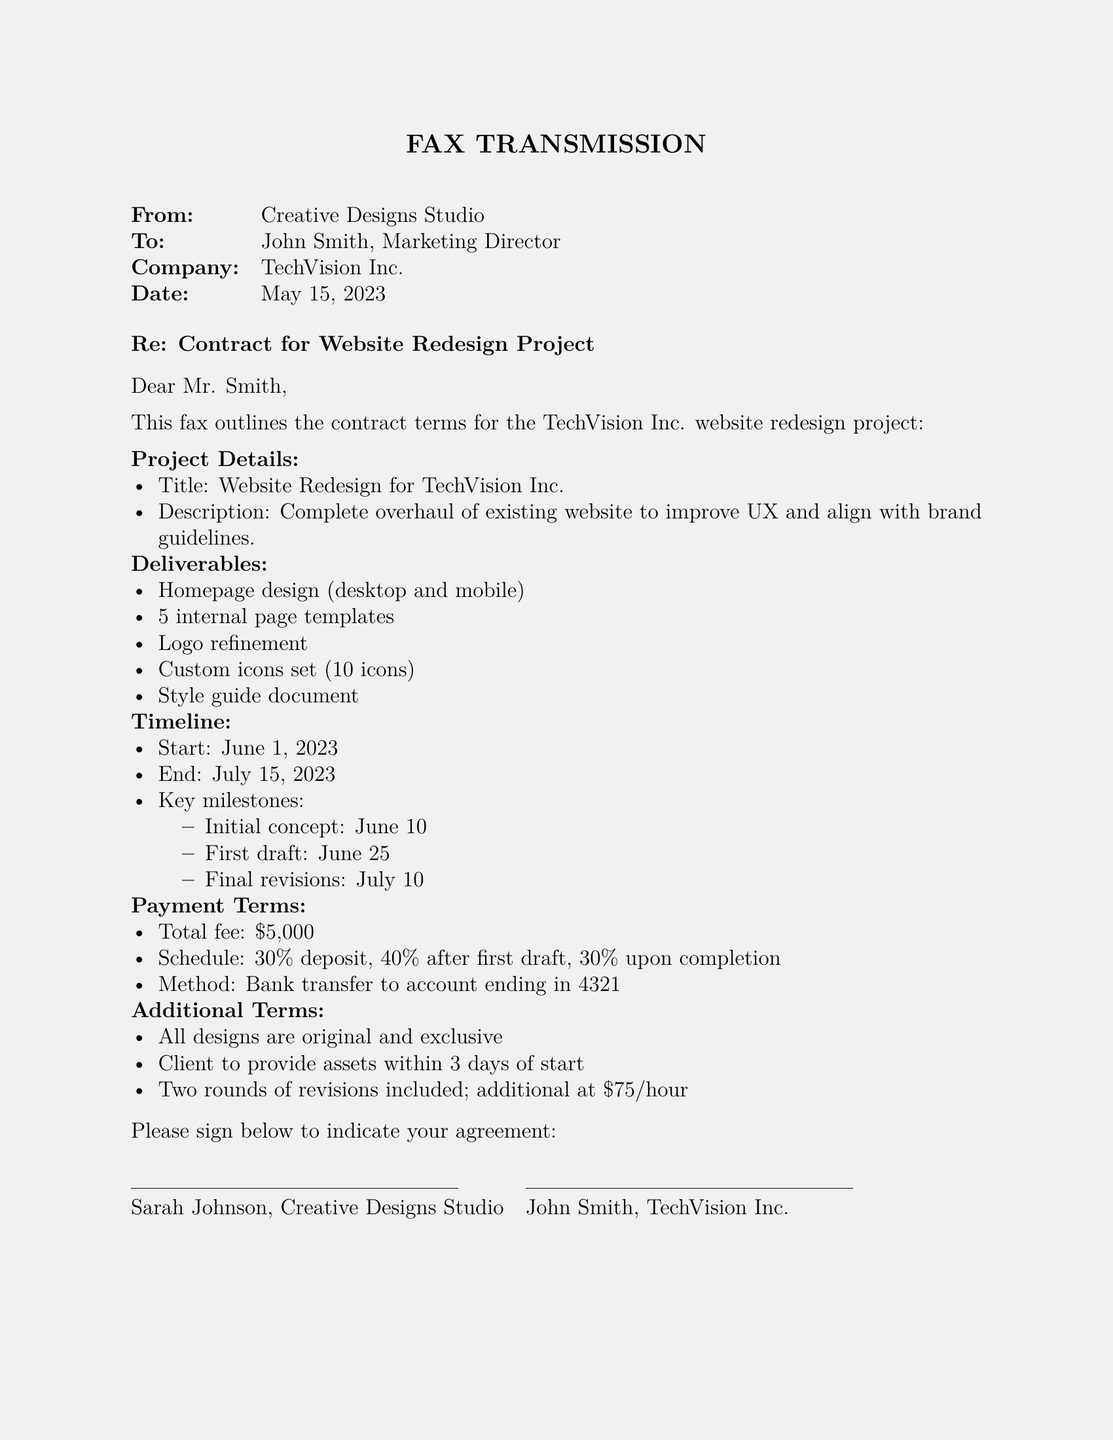What is the title of the project? The title is mentioned in the project details section, which states "Website Redesign for TechVision Inc."
Answer: Website Redesign for TechVision Inc Who is the recipient of the fax? The recipient is specified at the top of the document, under the "To" section.
Answer: John Smith What are the deliverables for the project? The deliverables section lists specific items, including homepage design and internal page templates.
Answer: Homepage design, 5 internal page templates, Logo refinement, Custom icons set, Style guide document When does the project start? The timeline section clearly states the start date of the project as June 1, 2023.
Answer: June 1, 2023 What is the total fee for the project? The payment terms section explicitly states the total fee of the project.
Answer: $5,000 How many revisions are included in the project? The additional terms specify the number of revisions included and the cost for additional ones.
Answer: Two What percentage is due after the first draft? The payment terms include a specific schedule outlining the percentages for payments.
Answer: 40% What date is the final revision scheduled for? The timeline outlines when the final revisions are due, indicating the specific date.
Answer: July 10 Who is the sender of the fax? The sender is noted at the top of the document, under the "From" section.
Answer: Creative Designs Studio 